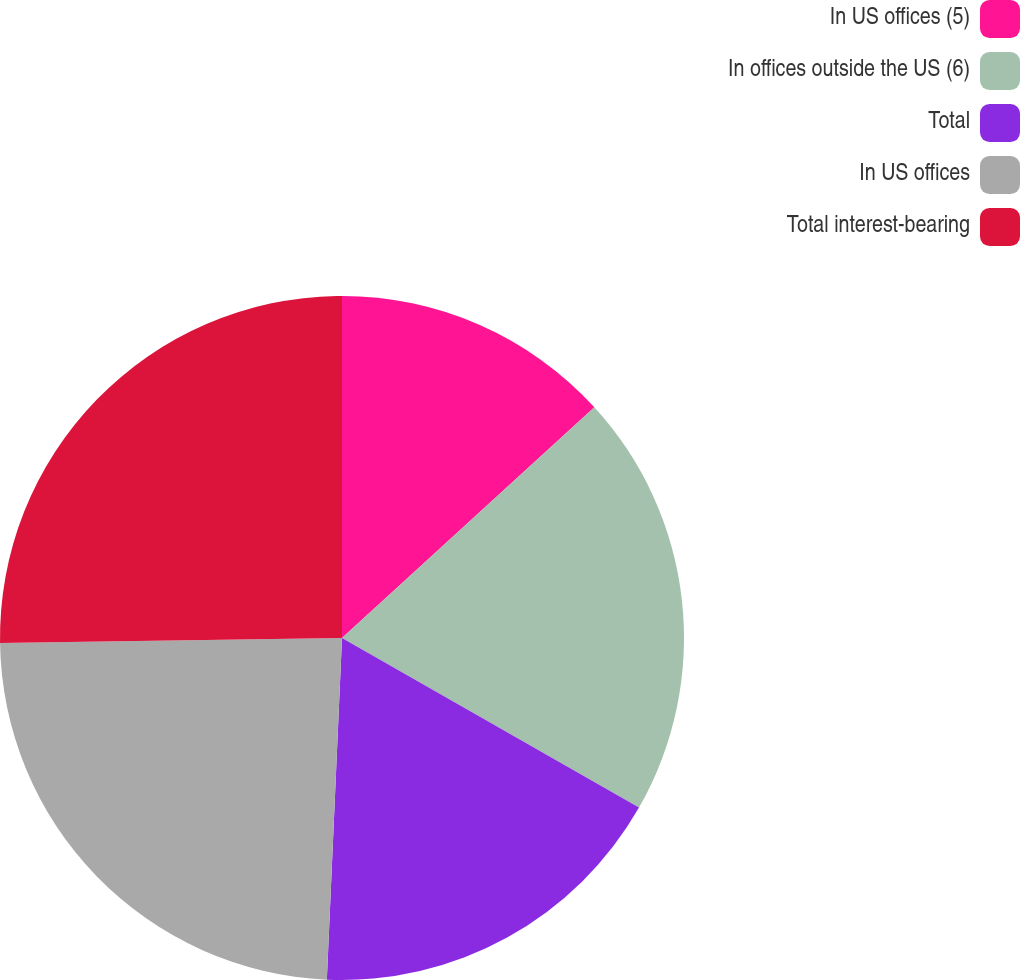Convert chart to OTSL. <chart><loc_0><loc_0><loc_500><loc_500><pie_chart><fcel>In US offices (5)<fcel>In offices outside the US (6)<fcel>Total<fcel>In US offices<fcel>Total interest-bearing<nl><fcel>13.21%<fcel>20.05%<fcel>17.45%<fcel>24.06%<fcel>25.24%<nl></chart> 